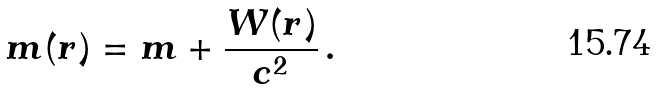Convert formula to latex. <formula><loc_0><loc_0><loc_500><loc_500>m ( r ) = m + \frac { W ( r ) } { c ^ { 2 } } \, .</formula> 